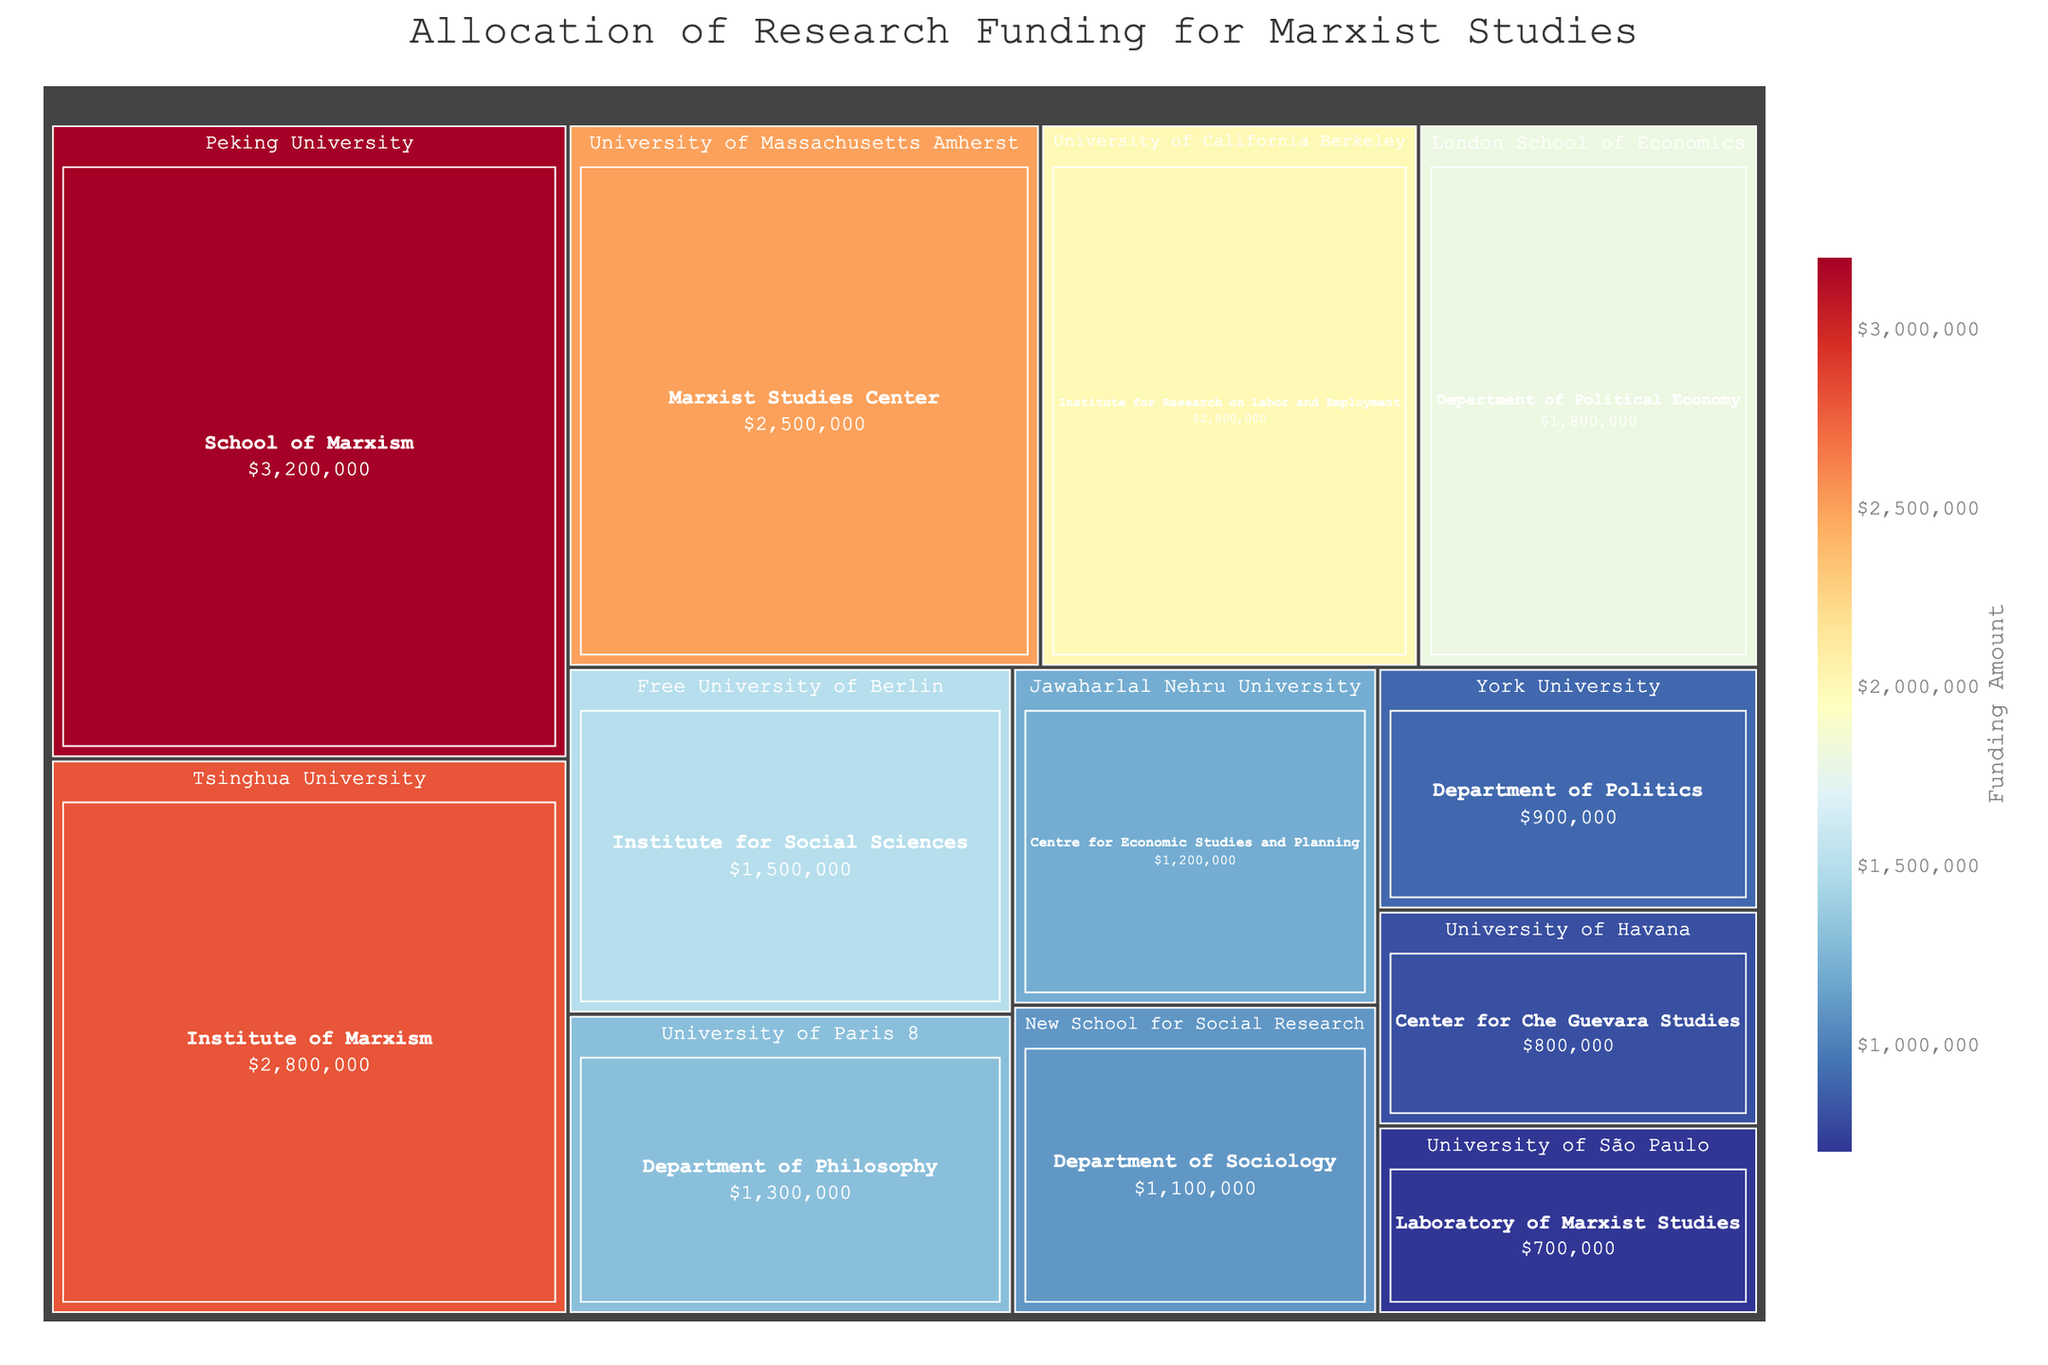What is the title of the treemap? The title is usually displayed prominently at the top or center of the plot, and it indicates the main topic or focus of the visualization.
Answer: Allocation of Research Funding for Marxist Studies Which institution has the highest amount of funding? By examining the size of the blocks and their labels, the institution with the largest block represents the highest amount of funding.
Answer: Peking University How much funding does the School of Marxism at Peking University receive? Hovering over or looking at the label of the block representing the School of Marxism at Peking University reveals the funding amount.
Answer: $3,200,000 Compare the funding amounts of the Institute of Marxism at Tsinghua University and the Marxist Studies Center at the University of Massachusetts Amherst. Which has more funding? Look at the sizes of the blocks for these departments and check their specific funding amounts.
Answer: Tsinghua University What is the total funding for the universities in China (Peking University and Tsinghua University)? Add the funding amounts for Peking University ($3,200,000) and Tsinghua University ($2,800,000).
Answer: $6,000,000 Which department receives the least amount of funding? Identify the smallest block in the treemap and check its label to find the department with the least funding.
Answer: Laboratory of Marxist Studies at the University of São Paulo What is the combined funding amount for the Department of Sociology at New School for Social Research and the Department of Politics at York University? Sum the funding amounts for both departments ($1,100,000 + $900,000).
Answer: $2,000,000 How many departments have a funding amount greater than $1,500,000? Count the number of blocks that represent funding amounts greater than $1,500,000 by examining their labels and sizes.
Answer: Five Does the University of Havana have more or less funding than the University of Paris 8? Compare the funding amounts of the Center for Che Guevara Studies at the University of Havana and the Department of Philosophy at the University of Paris 8.
Answer: Less Rank the following institutions by their funding amounts from highest to lowest: London School of Economics, Free University of Berlin, and University of California Berkeley. Compare the funding amounts of these institutions and arrange them in descending order.
Answer: University of California Berkeley, London School of Economics, Free University of Berlin 